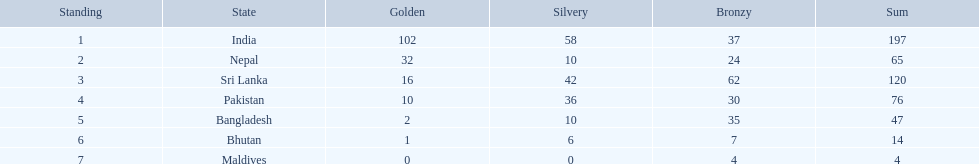What are all the countries listed in the table? India, Nepal, Sri Lanka, Pakistan, Bangladesh, Bhutan, Maldives. Which of these is not india? Nepal, Sri Lanka, Pakistan, Bangladesh, Bhutan, Maldives. Of these, which is first? Nepal. 